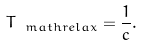Convert formula to latex. <formula><loc_0><loc_0><loc_500><loc_500>T _ { \ m a t h { r e l a x } } = \frac { 1 } { c } .</formula> 